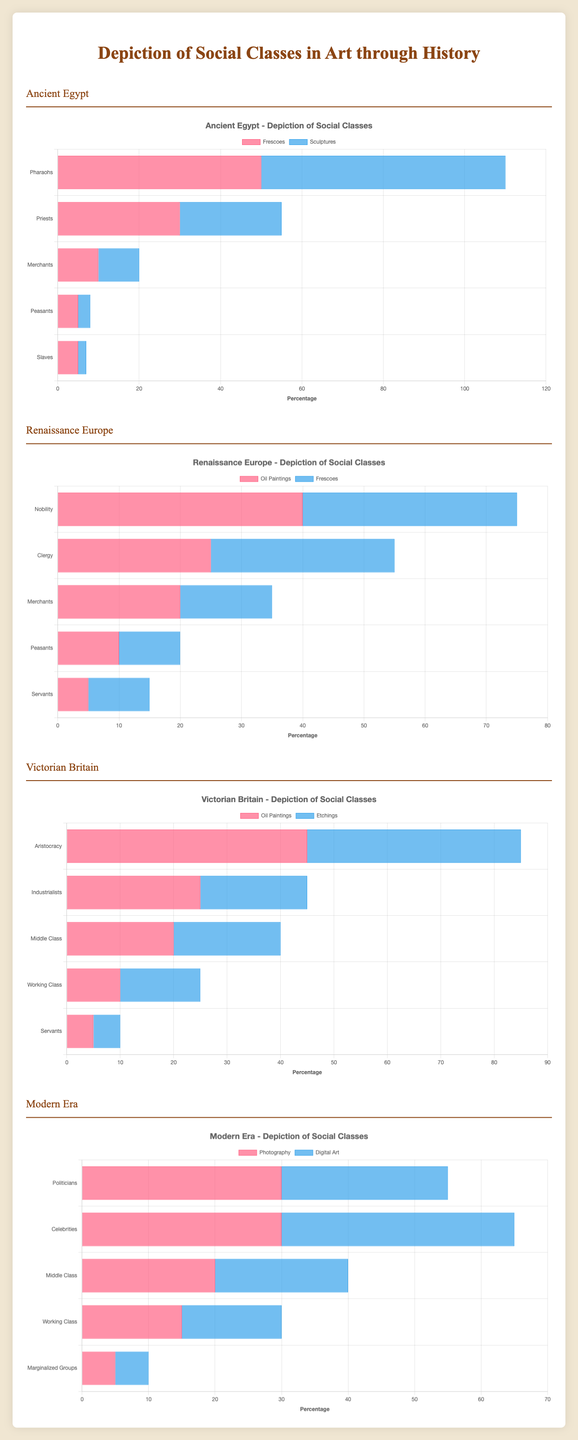What percentage of social classes depicted in Frescoes during Ancient Egypt were Peasants? In the Ancient Egypt Fresco data, the value for Peasants is 5%.
Answer: 5% Which social class is depicted more frequently in Victorian Britain's Oil Paintings compared to Etchings? For Oil Paintings, Aristocracy is depicted 45%, while in Etchings it is 40%. Thus, Aristocracy is depicted more frequently in Oil Paintings.
Answer: Aristocracy Compare the depiction of Merchants in Ancient Egypt Sculptures and Renaissance Europe Frescoes. Which is higher? In Ancient Egypt Sculptures, Merchants are depicted 10% and in Renaissance Europe Frescoes, they are depicted 15%.
Answer: Renaissance Europe Frescoes What is the total percentage of upper classes (Pharaohs + Priests) in Ancient Egypt Frescoes? Add Pharaohs (50%) and Priests (30%) together. Percentage = 50% + 30% = 80%.
Answer: 80% Which artistic style in the Modern Era depicts Celebrities the most? In the Modern Era, Celebrities are depicted 30% in Photography and 35% in Digital Art. Thus, Digital Art depicts Celebrities the most.
Answer: Digital Art What's the difference in percentage between Nobility and Clergy in Renaissance Europe Oil Paintings? Nobility is depicted 40%, and Clergy is depicted 25%. Difference = 40% - 25% = 15%.
Answer: 15% What color represents Frescoes in the Modern Era chart? The Frescoes form is not present within the Modern Era segment, and thus, no color represents Frescoes in Modern Era.
Answer: N/A Which era shows the highest depiction of the Middle Class in any art style? The depicted percentage for the Middle Class is 20% in both Victorian Britain's Oil Paintings and Etchings, and in the Modern Era's Photography and Digital Art. All equal but highest depicted.
Answer: Victorian Britain and Modern Era (Tie) What proportion of all social classes in Renaissance Europe Frescoes are Peasants and Servants combined? Peasants (10%) + Servants (10%) in Renaissance Europe Frescoes combine to form 20%.
Answer: 20% Is the depiction of Middle Class or Working Class higher in Modern Era Photography? In Modern Era Photography, Middle Class is depicted 20% and Working Class is depicted 15%.
Answer: Middle Class 